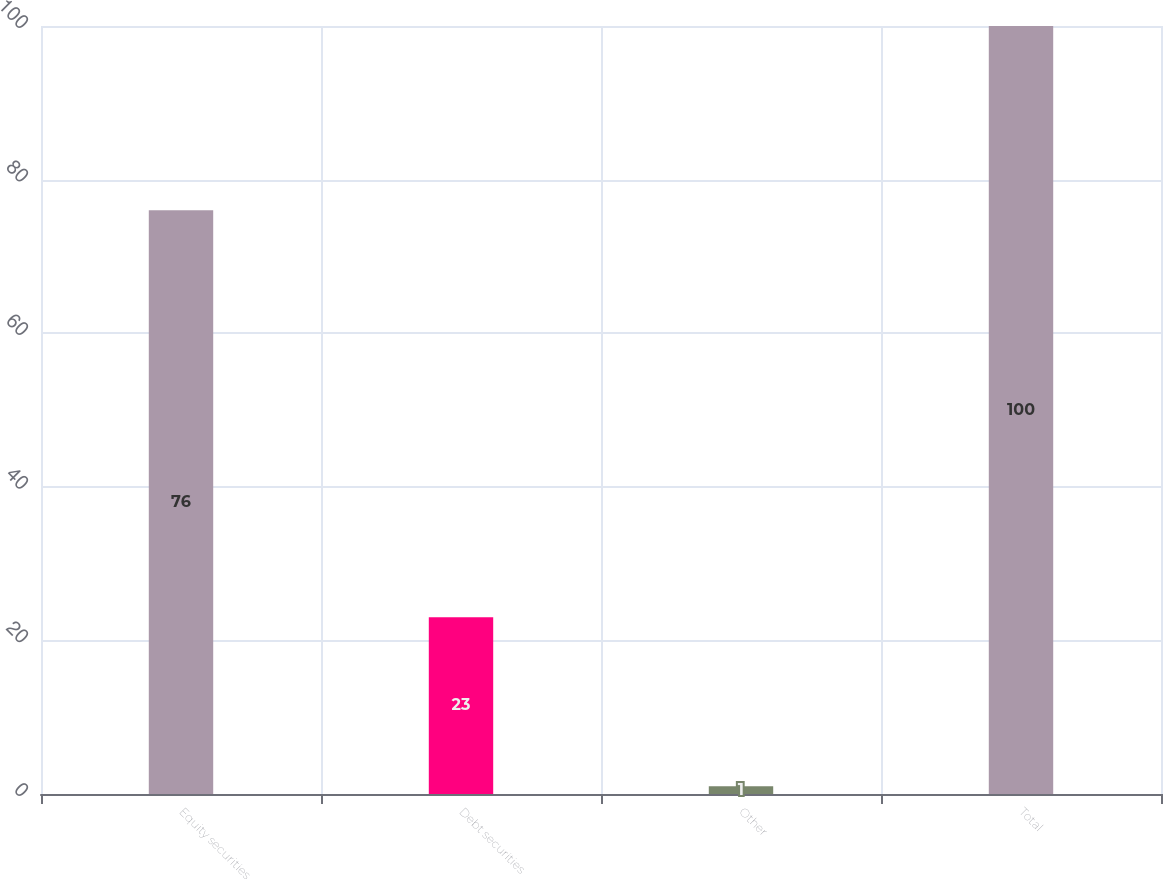<chart> <loc_0><loc_0><loc_500><loc_500><bar_chart><fcel>Equity securities<fcel>Debt securities<fcel>Other<fcel>Total<nl><fcel>76<fcel>23<fcel>1<fcel>100<nl></chart> 